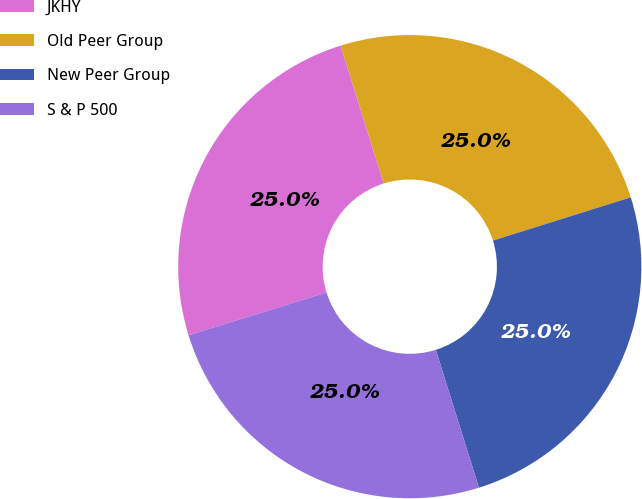<chart> <loc_0><loc_0><loc_500><loc_500><pie_chart><fcel>JKHY<fcel>Old Peer Group<fcel>New Peer Group<fcel>S & P 500<nl><fcel>24.96%<fcel>24.99%<fcel>25.01%<fcel>25.04%<nl></chart> 